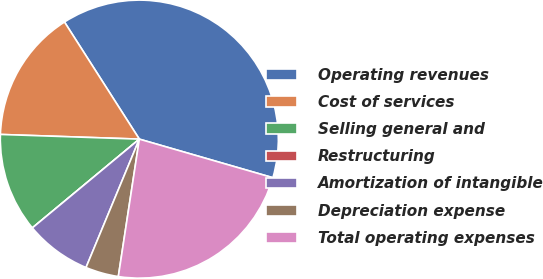Convert chart. <chart><loc_0><loc_0><loc_500><loc_500><pie_chart><fcel>Operating revenues<fcel>Cost of services<fcel>Selling general and<fcel>Restructuring<fcel>Amortization of intangible<fcel>Depreciation expense<fcel>Total operating expenses<nl><fcel>38.53%<fcel>15.41%<fcel>11.56%<fcel>0.0%<fcel>7.71%<fcel>3.85%<fcel>22.94%<nl></chart> 